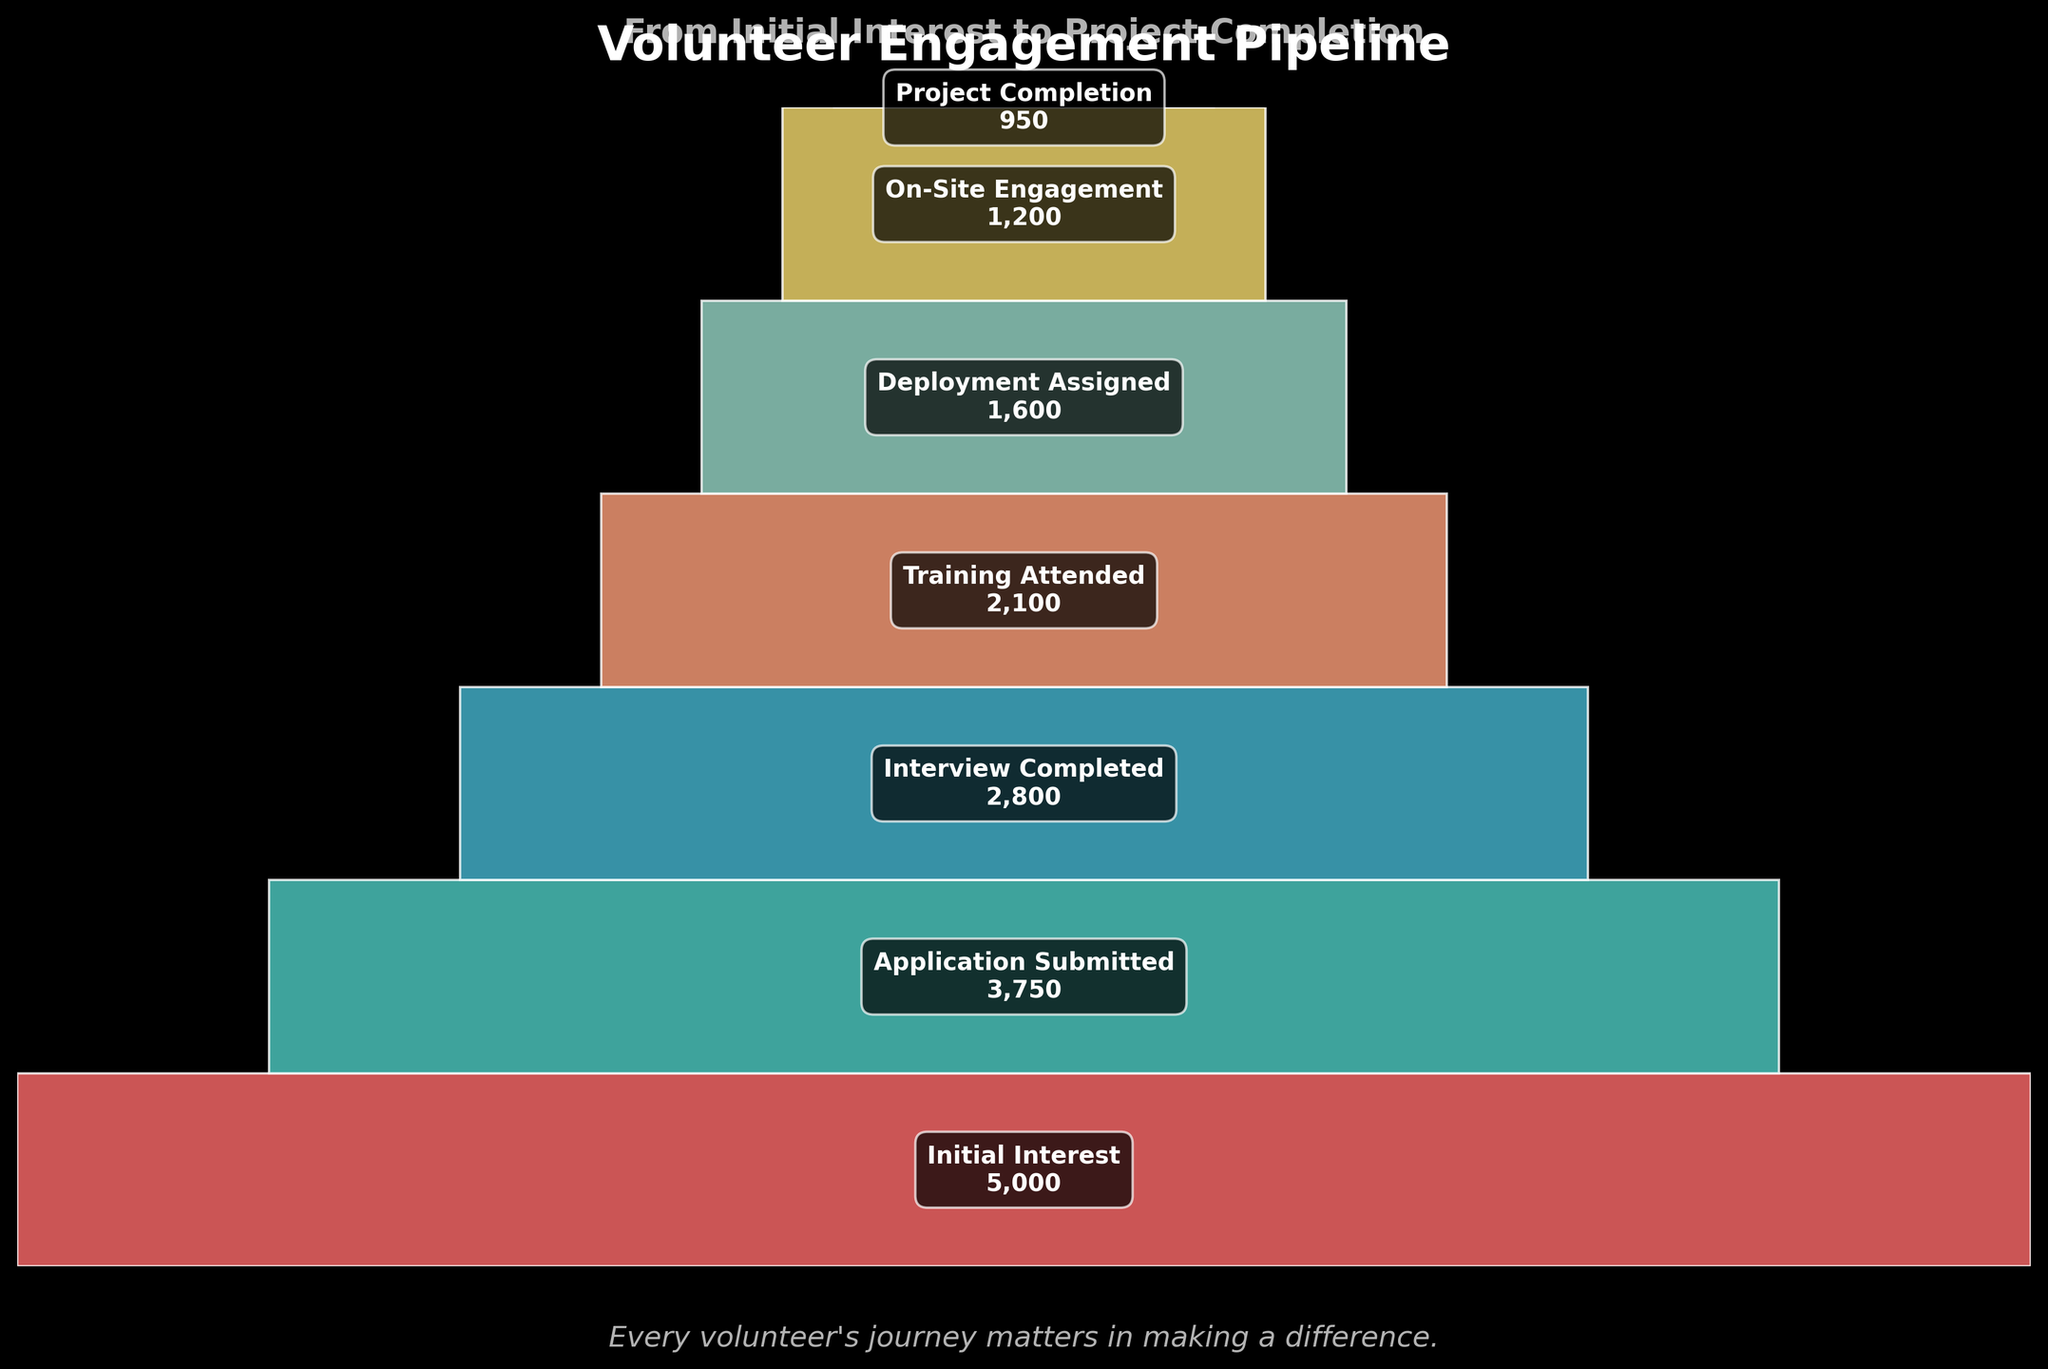Which stage has the highest number of volunteers? By looking at the funnel chart, the stage with the highest number of volunteers is displayed at the top. The topmost stage is labeled "Initial Interest" with 5000 volunteers.
Answer: Initial Interest Which stage has the lowest number of volunteers? The stage with the lowest number of volunteers can be found at the bottom of the funnel chart. The bottommost stage is labeled "Project Completion" with 950 volunteers.
Answer: Project Completion How many volunteers completed the interview process? The number of volunteers who completed the interview process is displayed next to the label "Interview Completed" in the funnel chart.
Answer: 2800 What is the difference in the number of volunteers between the "Application Submitted" and "On-Site Engagement" stages? The funnel chart shows 3750 volunteers at the "Application Submitted" stage and 1200 at the "On-Site Engagement" stage. Subtracting these values gives the difference: 3750 - 1200 = 2550.
Answer: 2550 How many volunteers dropped out between the "Training Attended" and "Deployment Assigned" stages? The chart shows 2100 volunteers at the "Training Attended" stage and 1600 at the "Deployment Assigned" stage. The difference is: 2100 - 1600 = 500.
Answer: 500 Which stage loses the highest number of volunteers compared to the previous stage? By examining the differences between consecutive stages: Initial Interest to Application Submitted (5000 - 3750 = 1250), Application Submitted to Interview Completed (3750 - 2800 = 950), Interview Completed to Training Attended (2800 - 2100 = 700), Training Attended to Deployment Assigned (2100 - 1600 = 500), Deployment Assigned to On-Site Engagement (1600 - 1200 = 400), On-Site Engagement to Project Completion (1200 - 950 = 250). The highest drop is 1250 between Initial Interest and Application Submitted.
Answer: Initial Interest to Application Submitted What percent of volunteers who attended training were assigned deployment? The funnel chart shows 2100 volunteers attended the training and 1600 assigned deployment. The percentage is calculated as (1600 / 2100) * 100 ≈ 76.2%.
Answer: 76.2% How many stages are there in the volunteer engagement pipeline? The funnel chart lists the stages from top to bottom, and there are seven labeled stages.
Answer: 7 What proportion of initial interested volunteers complete the project? From the chart, 5000 initially interested and 950 completed the project. The proportion is 950/5000, which simplifies to 0.19 or 19%.
Answer: 19% 